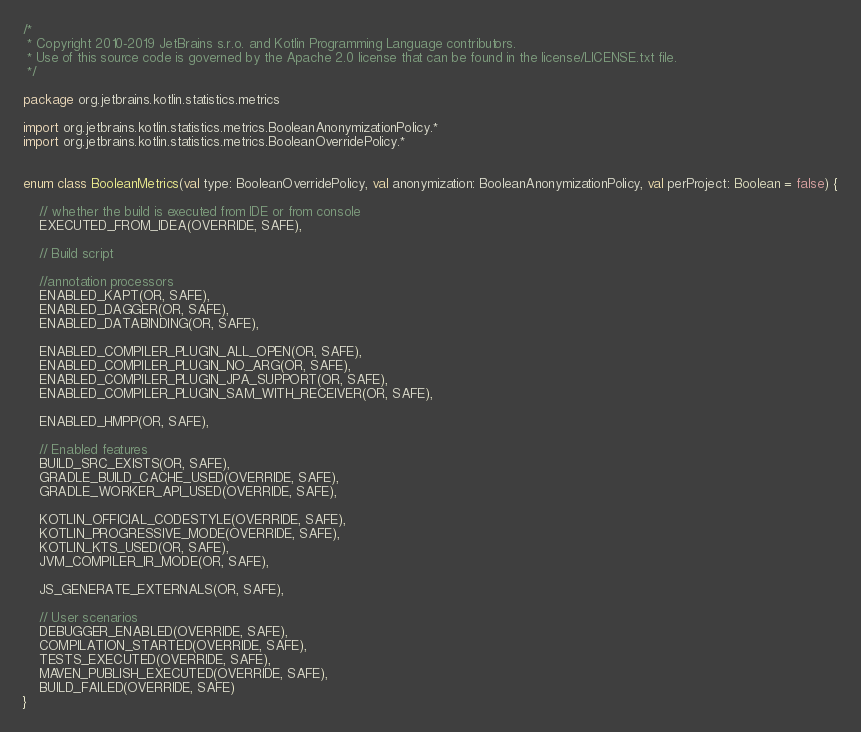Convert code to text. <code><loc_0><loc_0><loc_500><loc_500><_Kotlin_>/*
 * Copyright 2010-2019 JetBrains s.r.o. and Kotlin Programming Language contributors.
 * Use of this source code is governed by the Apache 2.0 license that can be found in the license/LICENSE.txt file.
 */

package org.jetbrains.kotlin.statistics.metrics

import org.jetbrains.kotlin.statistics.metrics.BooleanAnonymizationPolicy.*
import org.jetbrains.kotlin.statistics.metrics.BooleanOverridePolicy.*


enum class BooleanMetrics(val type: BooleanOverridePolicy, val anonymization: BooleanAnonymizationPolicy, val perProject: Boolean = false) {

    // whether the build is executed from IDE or from console
    EXECUTED_FROM_IDEA(OVERRIDE, SAFE),

    // Build script

    //annotation processors
    ENABLED_KAPT(OR, SAFE),
    ENABLED_DAGGER(OR, SAFE),
    ENABLED_DATABINDING(OR, SAFE),

    ENABLED_COMPILER_PLUGIN_ALL_OPEN(OR, SAFE),
    ENABLED_COMPILER_PLUGIN_NO_ARG(OR, SAFE),
    ENABLED_COMPILER_PLUGIN_JPA_SUPPORT(OR, SAFE),
    ENABLED_COMPILER_PLUGIN_SAM_WITH_RECEIVER(OR, SAFE),

    ENABLED_HMPP(OR, SAFE),

    // Enabled features
    BUILD_SRC_EXISTS(OR, SAFE),
    GRADLE_BUILD_CACHE_USED(OVERRIDE, SAFE),
    GRADLE_WORKER_API_USED(OVERRIDE, SAFE),

    KOTLIN_OFFICIAL_CODESTYLE(OVERRIDE, SAFE),
    KOTLIN_PROGRESSIVE_MODE(OVERRIDE, SAFE),
    KOTLIN_KTS_USED(OR, SAFE),
    JVM_COMPILER_IR_MODE(OR, SAFE),

    JS_GENERATE_EXTERNALS(OR, SAFE),

    // User scenarios
    DEBUGGER_ENABLED(OVERRIDE, SAFE),
    COMPILATION_STARTED(OVERRIDE, SAFE),
    TESTS_EXECUTED(OVERRIDE, SAFE),
    MAVEN_PUBLISH_EXECUTED(OVERRIDE, SAFE),
    BUILD_FAILED(OVERRIDE, SAFE)
}
</code> 